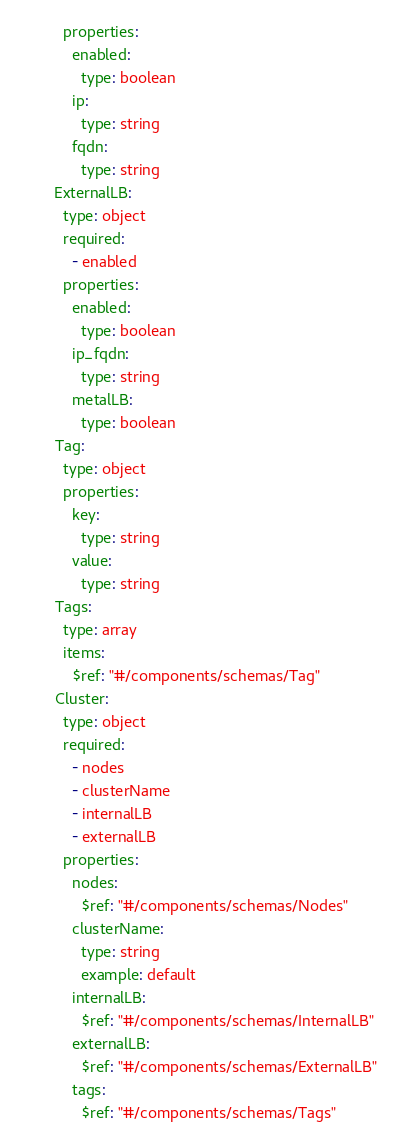Convert code to text. <code><loc_0><loc_0><loc_500><loc_500><_YAML_>      properties:
        enabled:
          type: boolean
        ip:
          type: string
        fqdn:
          type: string
    ExternalLB:
      type: object
      required:
        - enabled
      properties:
        enabled:
          type: boolean
        ip_fqdn:
          type: string
        metalLB:
          type: boolean
    Tag:
      type: object
      properties:
        key:
          type: string
        value:
          type: string
    Tags:
      type: array
      items:
        $ref: "#/components/schemas/Tag"
    Cluster:
      type: object
      required:
        - nodes
        - clusterName
        - internalLB
        - externalLB
      properties:
        nodes:
          $ref: "#/components/schemas/Nodes"
        clusterName:
          type: string
          example: default
        internalLB:
          $ref: "#/components/schemas/InternalLB"
        externalLB:
          $ref: "#/components/schemas/ExternalLB"
        tags:
          $ref: "#/components/schemas/Tags"
</code> 